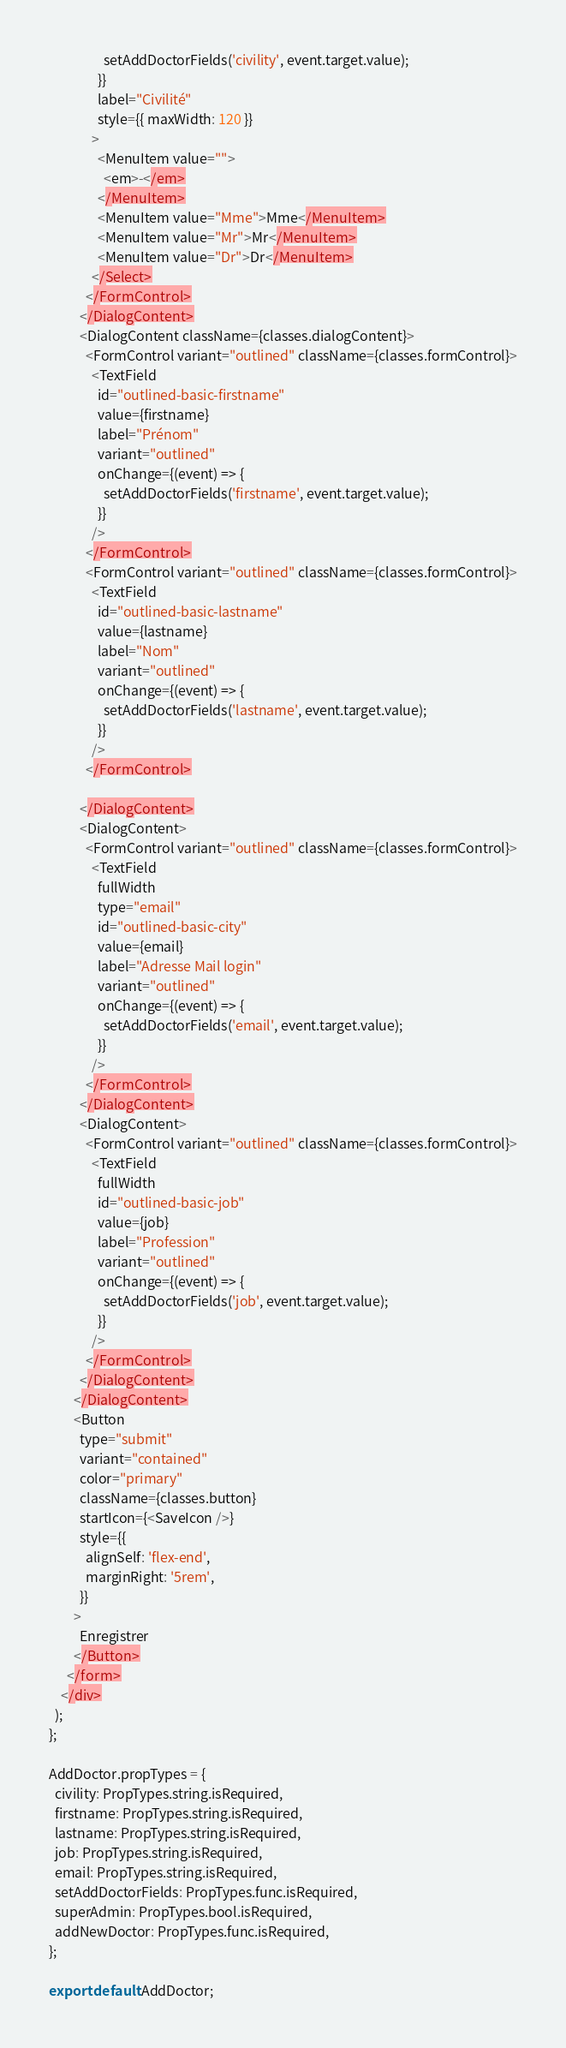Convert code to text. <code><loc_0><loc_0><loc_500><loc_500><_JavaScript_>                  setAddDoctorFields('civility', event.target.value);
                }}
                label="Civilité"
                style={{ maxWidth: 120 }}
              >
                <MenuItem value="">
                  <em>-</em>
                </MenuItem>
                <MenuItem value="Mme">Mme</MenuItem>
                <MenuItem value="Mr">Mr</MenuItem>
                <MenuItem value="Dr">Dr</MenuItem>
              </Select>
            </FormControl>
          </DialogContent>
          <DialogContent className={classes.dialogContent}>
            <FormControl variant="outlined" className={classes.formControl}>
              <TextField
                id="outlined-basic-firstname"
                value={firstname}
                label="Prénom"
                variant="outlined"
                onChange={(event) => {
                  setAddDoctorFields('firstname', event.target.value);
                }}
              />
            </FormControl>
            <FormControl variant="outlined" className={classes.formControl}>
              <TextField
                id="outlined-basic-lastname"
                value={lastname}
                label="Nom"
                variant="outlined"
                onChange={(event) => {
                  setAddDoctorFields('lastname', event.target.value);
                }}
              />
            </FormControl>

          </DialogContent>
          <DialogContent>
            <FormControl variant="outlined" className={classes.formControl}>
              <TextField
                fullWidth
                type="email"
                id="outlined-basic-city"
                value={email}
                label="Adresse Mail login"
                variant="outlined"
                onChange={(event) => {
                  setAddDoctorFields('email', event.target.value);
                }}
              />
            </FormControl>
          </DialogContent>
          <DialogContent>
            <FormControl variant="outlined" className={classes.formControl}>
              <TextField
                fullWidth
                id="outlined-basic-job"
                value={job}
                label="Profession"
                variant="outlined"
                onChange={(event) => {
                  setAddDoctorFields('job', event.target.value);
                }}
              />
            </FormControl>
          </DialogContent>
        </DialogContent>
        <Button
          type="submit"
          variant="contained"
          color="primary"
          className={classes.button}
          startIcon={<SaveIcon />}
          style={{
            alignSelf: 'flex-end',
            marginRight: '5rem',
          }}
        >
          Enregistrer
        </Button>
      </form>
    </div>
  );
};

AddDoctor.propTypes = {
  civility: PropTypes.string.isRequired,
  firstname: PropTypes.string.isRequired,
  lastname: PropTypes.string.isRequired,
  job: PropTypes.string.isRequired,
  email: PropTypes.string.isRequired,
  setAddDoctorFields: PropTypes.func.isRequired,
  superAdmin: PropTypes.bool.isRequired,
  addNewDoctor: PropTypes.func.isRequired,
};

export default AddDoctor;
</code> 